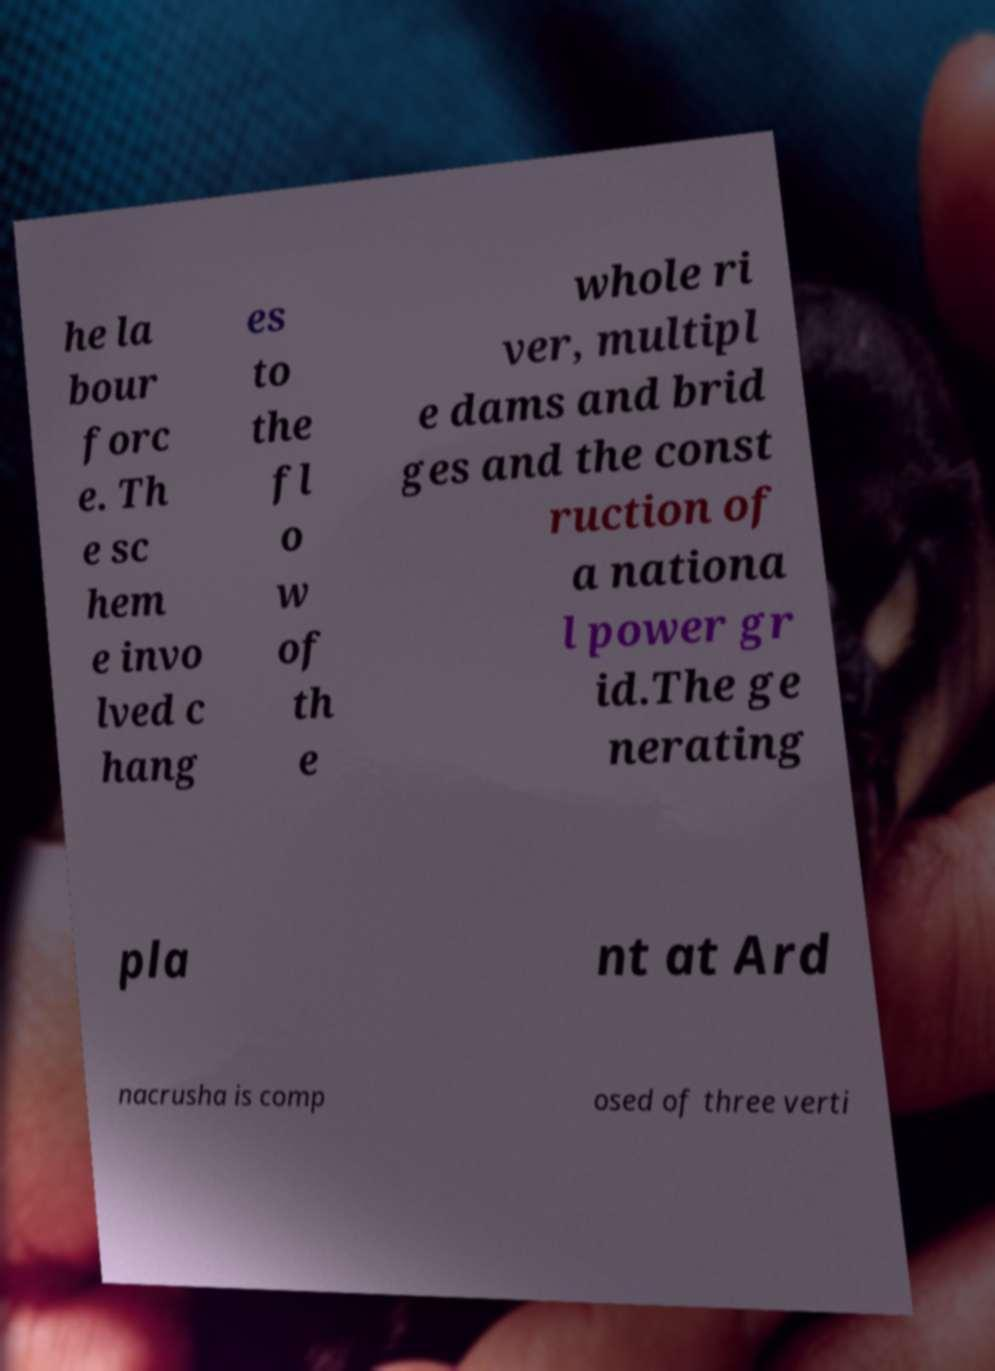I need the written content from this picture converted into text. Can you do that? he la bour forc e. Th e sc hem e invo lved c hang es to the fl o w of th e whole ri ver, multipl e dams and brid ges and the const ruction of a nationa l power gr id.The ge nerating pla nt at Ard nacrusha is comp osed of three verti 